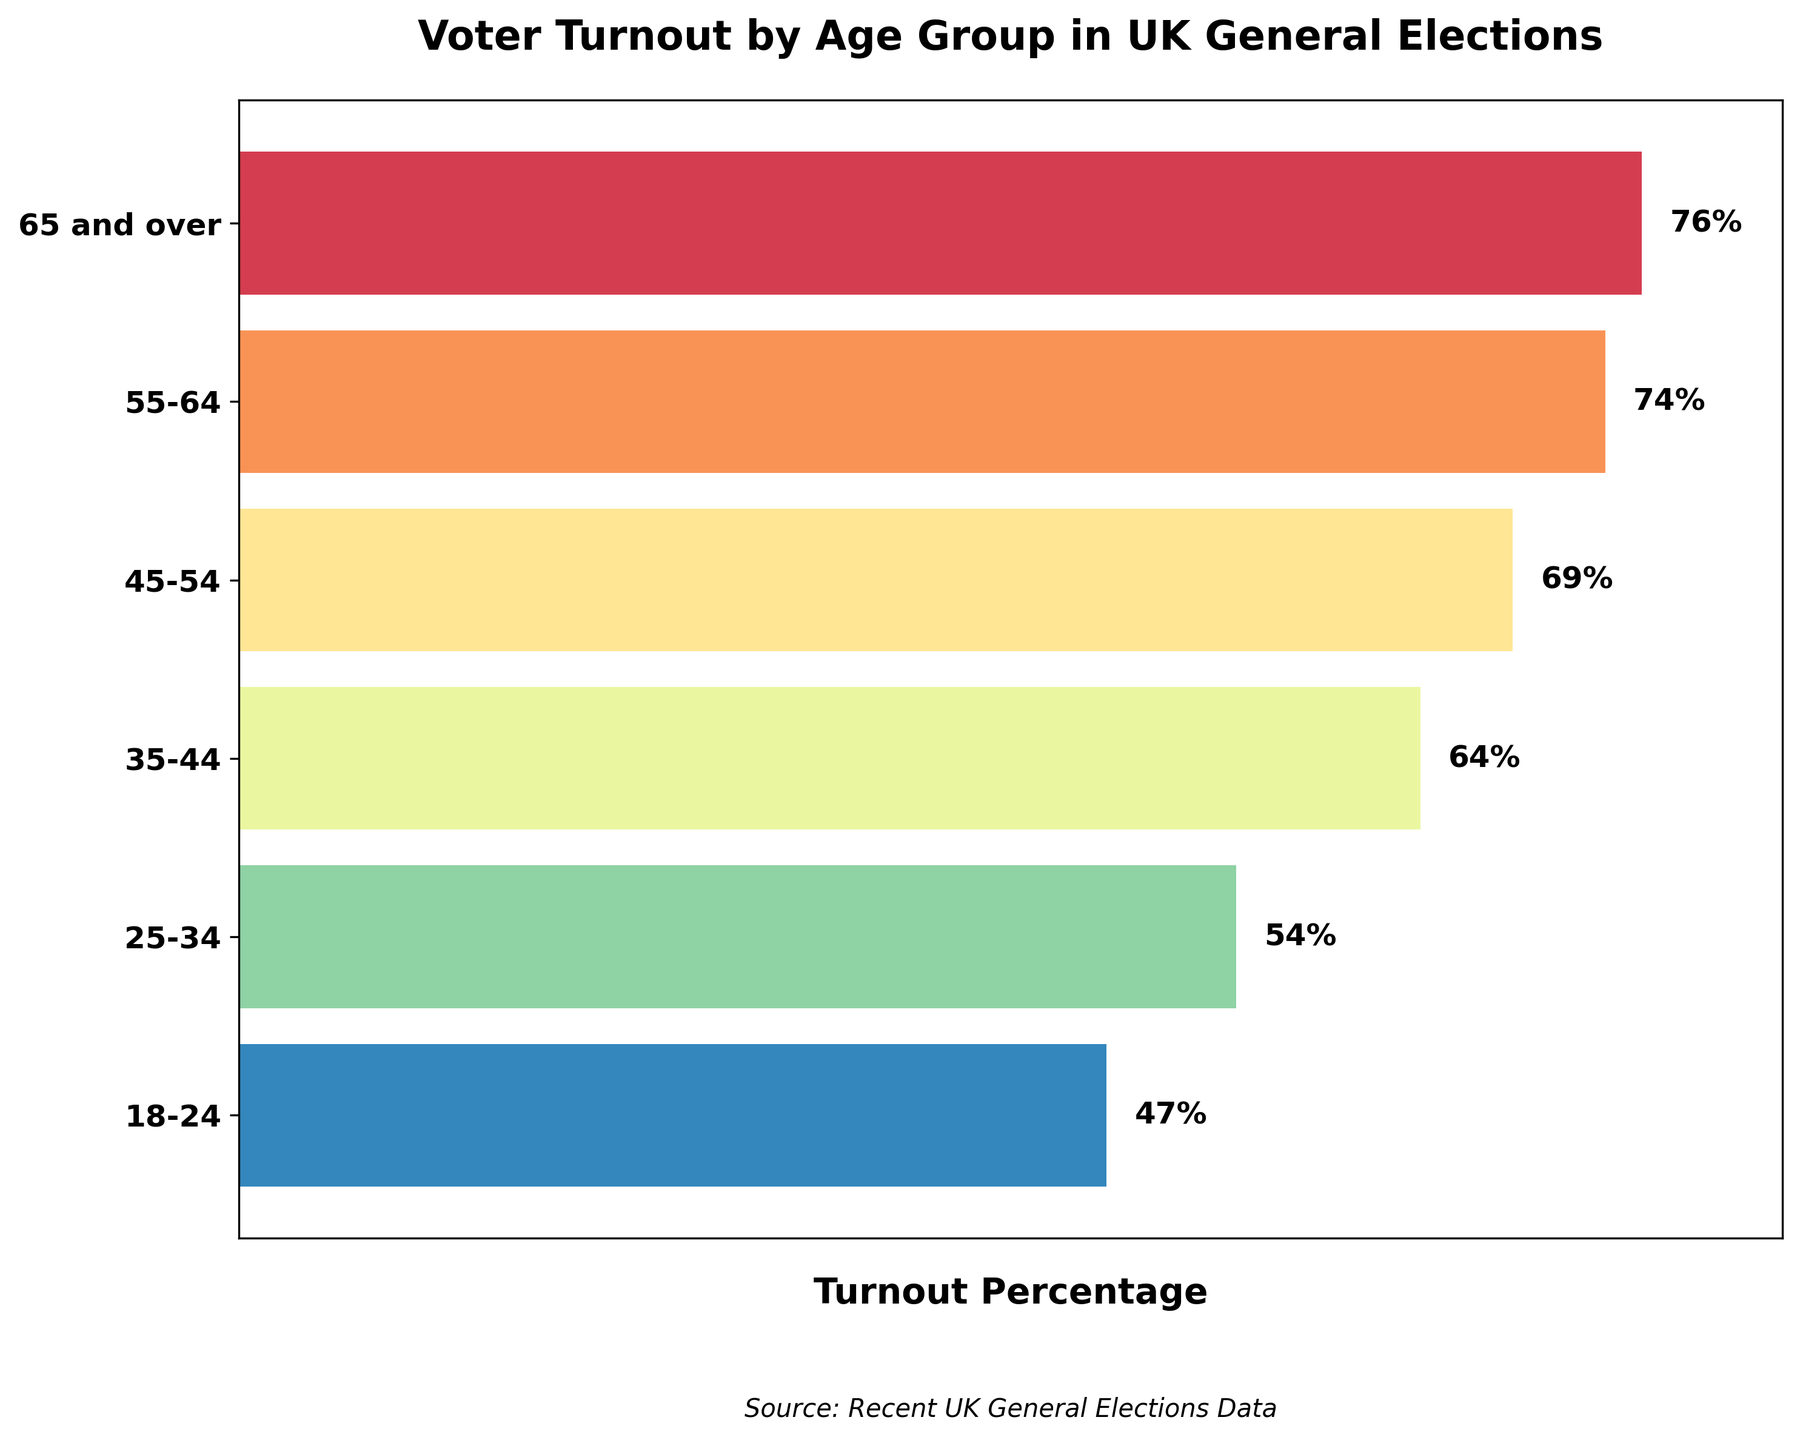What's the title of the figure? The title of a figure is usually placed at the top. In this figure, the title is clearly displayed.
Answer: Voter Turnout by Age Group in UK General Elections Which age group has the highest voter turnout percentage? By looking at the length of the bars in the figure, the longest bar represents the highest turnout percentage. The age group for this bar should be noted.
Answer: 65 and over What is the voter turnout percentage for the 18-24 age group? The figure displays percentages next to each bar. Locate the percentage next to the "18-24" age group on the y-axis.
Answer: 47% What is the difference in voter turnout percentage between the 65 and over group and the 18-24 group? Find the turnout percentages for both age groups from the figure, then subtract the smaller percentage from the larger one.
Answer: 29% (76% - 47%) Which age group has a turnout percentage between 60% and 70%? Identify the bars whose percentages fall within the range 60% to 70%. Note the corresponding age group(s).
Answer: 45-54 (69%), 35-44 (64%) Is the voter turnout percentage for the 55-64 age group greater than the 25-34 age group? Compare the lengths of the bars for the 55-64 and 25-34 age groups. The longer bar indicates a greater percentage.
Answer: Yes How many age groups have a voter turnout percentage above 70%? Count the numbers of bars that represent percentages higher than 70%.
Answer: 2 (65 and over, 55-64) What is the average voter turnout percentage for all age groups? Sum all the voter turnout percentages provided in the figure, then divide by the number of age groups (6) to find the average.
Answer: 64% ((76 + 74 + 69 + 64 + 54 + 47) / 6) Which age group has the second-highest voter turnout percentage? Identify the longest bar first and then find the second-longest bar to determine the second-highest turnout. Note the corresponding age group.
Answer: 55-64 (74%) What is the median voter turnout percentage across the age groups? List the voter turnout percentages in ascending or descending order: 47%, 54%, 64%, 69%, 74%, 76%. The median is the middle value for even-numbered groups, the average of the two central numbers.
Answer: 66.5% ((64 + 69) / 2) 